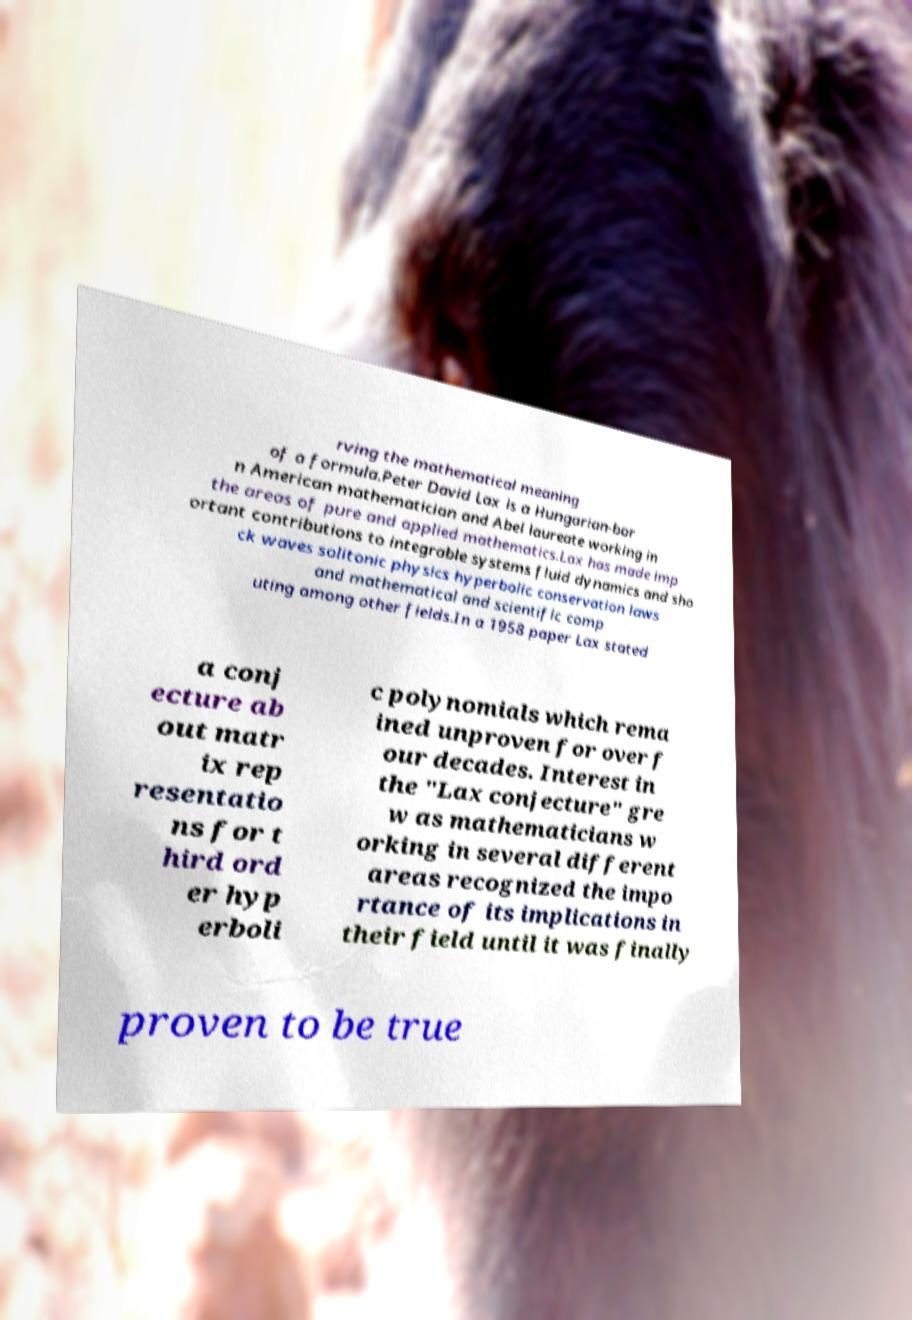What messages or text are displayed in this image? I need them in a readable, typed format. rving the mathematical meaning of a formula.Peter David Lax is a Hungarian-bor n American mathematician and Abel laureate working in the areas of pure and applied mathematics.Lax has made imp ortant contributions to integrable systems fluid dynamics and sho ck waves solitonic physics hyperbolic conservation laws and mathematical and scientific comp uting among other fields.In a 1958 paper Lax stated a conj ecture ab out matr ix rep resentatio ns for t hird ord er hyp erboli c polynomials which rema ined unproven for over f our decades. Interest in the "Lax conjecture" gre w as mathematicians w orking in several different areas recognized the impo rtance of its implications in their field until it was finally proven to be true 